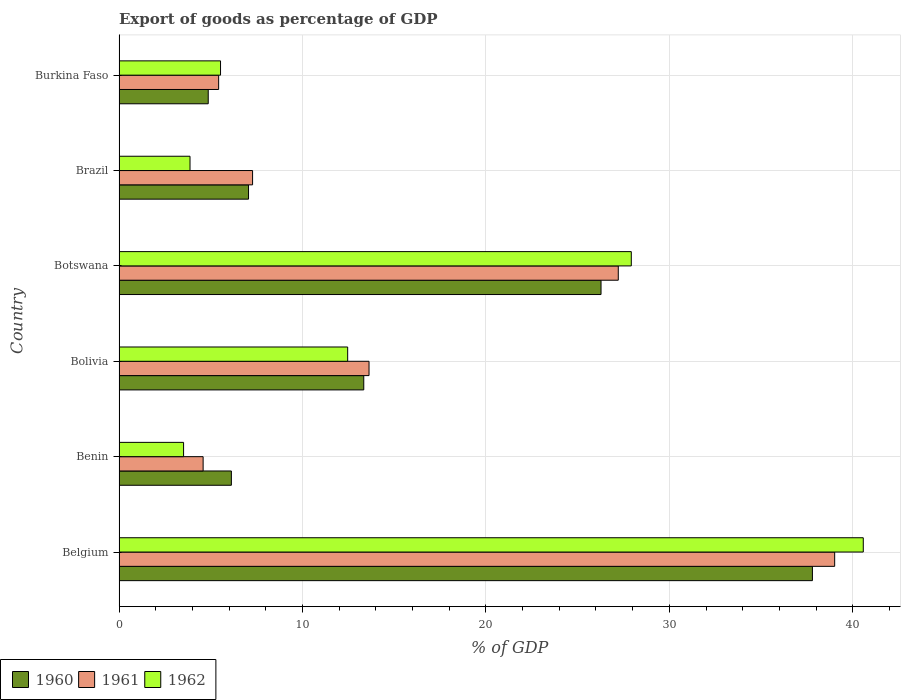How many different coloured bars are there?
Offer a terse response. 3. How many groups of bars are there?
Make the answer very short. 6. Are the number of bars on each tick of the Y-axis equal?
Provide a short and direct response. Yes. What is the label of the 2nd group of bars from the top?
Provide a short and direct response. Brazil. What is the export of goods as percentage of GDP in 1960 in Brazil?
Keep it short and to the point. 7.06. Across all countries, what is the maximum export of goods as percentage of GDP in 1960?
Provide a succinct answer. 37.8. Across all countries, what is the minimum export of goods as percentage of GDP in 1960?
Give a very brief answer. 4.86. In which country was the export of goods as percentage of GDP in 1961 maximum?
Give a very brief answer. Belgium. In which country was the export of goods as percentage of GDP in 1960 minimum?
Make the answer very short. Burkina Faso. What is the total export of goods as percentage of GDP in 1960 in the graph?
Your answer should be compact. 95.46. What is the difference between the export of goods as percentage of GDP in 1960 in Bolivia and that in Burkina Faso?
Your answer should be compact. 8.48. What is the difference between the export of goods as percentage of GDP in 1961 in Brazil and the export of goods as percentage of GDP in 1962 in Botswana?
Give a very brief answer. -20.65. What is the average export of goods as percentage of GDP in 1962 per country?
Your answer should be very brief. 15.65. What is the difference between the export of goods as percentage of GDP in 1962 and export of goods as percentage of GDP in 1961 in Bolivia?
Provide a succinct answer. -1.16. What is the ratio of the export of goods as percentage of GDP in 1961 in Bolivia to that in Brazil?
Offer a terse response. 1.87. Is the export of goods as percentage of GDP in 1961 in Brazil less than that in Burkina Faso?
Keep it short and to the point. No. Is the difference between the export of goods as percentage of GDP in 1962 in Botswana and Brazil greater than the difference between the export of goods as percentage of GDP in 1961 in Botswana and Brazil?
Provide a succinct answer. Yes. What is the difference between the highest and the second highest export of goods as percentage of GDP in 1960?
Offer a very short reply. 11.53. What is the difference between the highest and the lowest export of goods as percentage of GDP in 1962?
Keep it short and to the point. 37.06. What does the 3rd bar from the top in Bolivia represents?
Your answer should be compact. 1960. Is it the case that in every country, the sum of the export of goods as percentage of GDP in 1960 and export of goods as percentage of GDP in 1962 is greater than the export of goods as percentage of GDP in 1961?
Ensure brevity in your answer.  Yes. Where does the legend appear in the graph?
Provide a short and direct response. Bottom left. How are the legend labels stacked?
Your response must be concise. Horizontal. What is the title of the graph?
Keep it short and to the point. Export of goods as percentage of GDP. What is the label or title of the X-axis?
Give a very brief answer. % of GDP. What is the label or title of the Y-axis?
Make the answer very short. Country. What is the % of GDP in 1960 in Belgium?
Offer a very short reply. 37.8. What is the % of GDP in 1961 in Belgium?
Your answer should be very brief. 39.01. What is the % of GDP of 1962 in Belgium?
Your answer should be very brief. 40.57. What is the % of GDP in 1960 in Benin?
Offer a very short reply. 6.12. What is the % of GDP of 1961 in Benin?
Give a very brief answer. 4.58. What is the % of GDP of 1962 in Benin?
Keep it short and to the point. 3.52. What is the % of GDP in 1960 in Bolivia?
Ensure brevity in your answer.  13.34. What is the % of GDP of 1961 in Bolivia?
Ensure brevity in your answer.  13.63. What is the % of GDP of 1962 in Bolivia?
Your response must be concise. 12.46. What is the % of GDP in 1960 in Botswana?
Your answer should be compact. 26.28. What is the % of GDP in 1961 in Botswana?
Your response must be concise. 27.22. What is the % of GDP of 1962 in Botswana?
Your answer should be compact. 27.93. What is the % of GDP in 1960 in Brazil?
Provide a succinct answer. 7.06. What is the % of GDP of 1961 in Brazil?
Offer a very short reply. 7.28. What is the % of GDP in 1962 in Brazil?
Your answer should be very brief. 3.87. What is the % of GDP in 1960 in Burkina Faso?
Your response must be concise. 4.86. What is the % of GDP of 1961 in Burkina Faso?
Give a very brief answer. 5.43. What is the % of GDP of 1962 in Burkina Faso?
Offer a very short reply. 5.53. Across all countries, what is the maximum % of GDP in 1960?
Ensure brevity in your answer.  37.8. Across all countries, what is the maximum % of GDP of 1961?
Ensure brevity in your answer.  39.01. Across all countries, what is the maximum % of GDP of 1962?
Provide a short and direct response. 40.57. Across all countries, what is the minimum % of GDP in 1960?
Keep it short and to the point. 4.86. Across all countries, what is the minimum % of GDP in 1961?
Ensure brevity in your answer.  4.58. Across all countries, what is the minimum % of GDP in 1962?
Your answer should be very brief. 3.52. What is the total % of GDP in 1960 in the graph?
Offer a terse response. 95.46. What is the total % of GDP in 1961 in the graph?
Your answer should be very brief. 97.15. What is the total % of GDP in 1962 in the graph?
Your response must be concise. 93.88. What is the difference between the % of GDP in 1960 in Belgium and that in Benin?
Provide a succinct answer. 31.68. What is the difference between the % of GDP in 1961 in Belgium and that in Benin?
Give a very brief answer. 34.43. What is the difference between the % of GDP in 1962 in Belgium and that in Benin?
Offer a terse response. 37.06. What is the difference between the % of GDP of 1960 in Belgium and that in Bolivia?
Your answer should be very brief. 24.46. What is the difference between the % of GDP in 1961 in Belgium and that in Bolivia?
Give a very brief answer. 25.39. What is the difference between the % of GDP of 1962 in Belgium and that in Bolivia?
Provide a short and direct response. 28.11. What is the difference between the % of GDP in 1960 in Belgium and that in Botswana?
Your answer should be compact. 11.53. What is the difference between the % of GDP of 1961 in Belgium and that in Botswana?
Offer a very short reply. 11.8. What is the difference between the % of GDP in 1962 in Belgium and that in Botswana?
Your answer should be very brief. 12.65. What is the difference between the % of GDP in 1960 in Belgium and that in Brazil?
Make the answer very short. 30.74. What is the difference between the % of GDP of 1961 in Belgium and that in Brazil?
Provide a succinct answer. 31.73. What is the difference between the % of GDP of 1962 in Belgium and that in Brazil?
Provide a succinct answer. 36.7. What is the difference between the % of GDP of 1960 in Belgium and that in Burkina Faso?
Your response must be concise. 32.94. What is the difference between the % of GDP in 1961 in Belgium and that in Burkina Faso?
Your answer should be compact. 33.58. What is the difference between the % of GDP of 1962 in Belgium and that in Burkina Faso?
Offer a very short reply. 35.04. What is the difference between the % of GDP of 1960 in Benin and that in Bolivia?
Give a very brief answer. -7.22. What is the difference between the % of GDP in 1961 in Benin and that in Bolivia?
Provide a succinct answer. -9.04. What is the difference between the % of GDP of 1962 in Benin and that in Bolivia?
Your answer should be very brief. -8.95. What is the difference between the % of GDP in 1960 in Benin and that in Botswana?
Give a very brief answer. -20.15. What is the difference between the % of GDP in 1961 in Benin and that in Botswana?
Your answer should be very brief. -22.63. What is the difference between the % of GDP of 1962 in Benin and that in Botswana?
Give a very brief answer. -24.41. What is the difference between the % of GDP of 1960 in Benin and that in Brazil?
Your response must be concise. -0.94. What is the difference between the % of GDP in 1961 in Benin and that in Brazil?
Provide a short and direct response. -2.7. What is the difference between the % of GDP of 1962 in Benin and that in Brazil?
Keep it short and to the point. -0.35. What is the difference between the % of GDP of 1960 in Benin and that in Burkina Faso?
Provide a short and direct response. 1.26. What is the difference between the % of GDP in 1961 in Benin and that in Burkina Faso?
Make the answer very short. -0.85. What is the difference between the % of GDP in 1962 in Benin and that in Burkina Faso?
Your answer should be very brief. -2.01. What is the difference between the % of GDP of 1960 in Bolivia and that in Botswana?
Provide a short and direct response. -12.93. What is the difference between the % of GDP of 1961 in Bolivia and that in Botswana?
Your response must be concise. -13.59. What is the difference between the % of GDP in 1962 in Bolivia and that in Botswana?
Provide a succinct answer. -15.46. What is the difference between the % of GDP in 1960 in Bolivia and that in Brazil?
Your response must be concise. 6.28. What is the difference between the % of GDP of 1961 in Bolivia and that in Brazil?
Ensure brevity in your answer.  6.35. What is the difference between the % of GDP of 1962 in Bolivia and that in Brazil?
Your response must be concise. 8.6. What is the difference between the % of GDP in 1960 in Bolivia and that in Burkina Faso?
Make the answer very short. 8.48. What is the difference between the % of GDP of 1961 in Bolivia and that in Burkina Faso?
Offer a very short reply. 8.2. What is the difference between the % of GDP in 1962 in Bolivia and that in Burkina Faso?
Provide a short and direct response. 6.93. What is the difference between the % of GDP of 1960 in Botswana and that in Brazil?
Offer a terse response. 19.22. What is the difference between the % of GDP of 1961 in Botswana and that in Brazil?
Your answer should be very brief. 19.94. What is the difference between the % of GDP in 1962 in Botswana and that in Brazil?
Offer a terse response. 24.06. What is the difference between the % of GDP of 1960 in Botswana and that in Burkina Faso?
Your response must be concise. 21.41. What is the difference between the % of GDP of 1961 in Botswana and that in Burkina Faso?
Keep it short and to the point. 21.79. What is the difference between the % of GDP of 1962 in Botswana and that in Burkina Faso?
Give a very brief answer. 22.39. What is the difference between the % of GDP of 1960 in Brazil and that in Burkina Faso?
Provide a short and direct response. 2.2. What is the difference between the % of GDP in 1961 in Brazil and that in Burkina Faso?
Your answer should be compact. 1.85. What is the difference between the % of GDP in 1962 in Brazil and that in Burkina Faso?
Make the answer very short. -1.66. What is the difference between the % of GDP of 1960 in Belgium and the % of GDP of 1961 in Benin?
Your response must be concise. 33.22. What is the difference between the % of GDP of 1960 in Belgium and the % of GDP of 1962 in Benin?
Your answer should be very brief. 34.28. What is the difference between the % of GDP in 1961 in Belgium and the % of GDP in 1962 in Benin?
Make the answer very short. 35.5. What is the difference between the % of GDP of 1960 in Belgium and the % of GDP of 1961 in Bolivia?
Keep it short and to the point. 24.17. What is the difference between the % of GDP of 1960 in Belgium and the % of GDP of 1962 in Bolivia?
Offer a very short reply. 25.34. What is the difference between the % of GDP in 1961 in Belgium and the % of GDP in 1962 in Bolivia?
Make the answer very short. 26.55. What is the difference between the % of GDP in 1960 in Belgium and the % of GDP in 1961 in Botswana?
Provide a short and direct response. 10.58. What is the difference between the % of GDP of 1960 in Belgium and the % of GDP of 1962 in Botswana?
Your answer should be very brief. 9.87. What is the difference between the % of GDP of 1961 in Belgium and the % of GDP of 1962 in Botswana?
Offer a terse response. 11.09. What is the difference between the % of GDP in 1960 in Belgium and the % of GDP in 1961 in Brazil?
Make the answer very short. 30.52. What is the difference between the % of GDP in 1960 in Belgium and the % of GDP in 1962 in Brazil?
Offer a very short reply. 33.93. What is the difference between the % of GDP in 1961 in Belgium and the % of GDP in 1962 in Brazil?
Keep it short and to the point. 35.14. What is the difference between the % of GDP of 1960 in Belgium and the % of GDP of 1961 in Burkina Faso?
Ensure brevity in your answer.  32.37. What is the difference between the % of GDP in 1960 in Belgium and the % of GDP in 1962 in Burkina Faso?
Offer a very short reply. 32.27. What is the difference between the % of GDP of 1961 in Belgium and the % of GDP of 1962 in Burkina Faso?
Give a very brief answer. 33.48. What is the difference between the % of GDP of 1960 in Benin and the % of GDP of 1961 in Bolivia?
Keep it short and to the point. -7.5. What is the difference between the % of GDP in 1960 in Benin and the % of GDP in 1962 in Bolivia?
Keep it short and to the point. -6.34. What is the difference between the % of GDP in 1961 in Benin and the % of GDP in 1962 in Bolivia?
Ensure brevity in your answer.  -7.88. What is the difference between the % of GDP of 1960 in Benin and the % of GDP of 1961 in Botswana?
Your answer should be very brief. -21.09. What is the difference between the % of GDP of 1960 in Benin and the % of GDP of 1962 in Botswana?
Your response must be concise. -21.8. What is the difference between the % of GDP in 1961 in Benin and the % of GDP in 1962 in Botswana?
Ensure brevity in your answer.  -23.34. What is the difference between the % of GDP in 1960 in Benin and the % of GDP in 1961 in Brazil?
Ensure brevity in your answer.  -1.16. What is the difference between the % of GDP in 1960 in Benin and the % of GDP in 1962 in Brazil?
Give a very brief answer. 2.26. What is the difference between the % of GDP in 1961 in Benin and the % of GDP in 1962 in Brazil?
Ensure brevity in your answer.  0.71. What is the difference between the % of GDP in 1960 in Benin and the % of GDP in 1961 in Burkina Faso?
Provide a succinct answer. 0.69. What is the difference between the % of GDP in 1960 in Benin and the % of GDP in 1962 in Burkina Faso?
Your response must be concise. 0.59. What is the difference between the % of GDP in 1961 in Benin and the % of GDP in 1962 in Burkina Faso?
Give a very brief answer. -0.95. What is the difference between the % of GDP in 1960 in Bolivia and the % of GDP in 1961 in Botswana?
Provide a succinct answer. -13.88. What is the difference between the % of GDP of 1960 in Bolivia and the % of GDP of 1962 in Botswana?
Your answer should be compact. -14.58. What is the difference between the % of GDP in 1961 in Bolivia and the % of GDP in 1962 in Botswana?
Your response must be concise. -14.3. What is the difference between the % of GDP in 1960 in Bolivia and the % of GDP in 1961 in Brazil?
Ensure brevity in your answer.  6.06. What is the difference between the % of GDP of 1960 in Bolivia and the % of GDP of 1962 in Brazil?
Offer a very short reply. 9.47. What is the difference between the % of GDP in 1961 in Bolivia and the % of GDP in 1962 in Brazil?
Give a very brief answer. 9.76. What is the difference between the % of GDP in 1960 in Bolivia and the % of GDP in 1961 in Burkina Faso?
Your answer should be compact. 7.91. What is the difference between the % of GDP of 1960 in Bolivia and the % of GDP of 1962 in Burkina Faso?
Offer a terse response. 7.81. What is the difference between the % of GDP of 1961 in Bolivia and the % of GDP of 1962 in Burkina Faso?
Your answer should be very brief. 8.1. What is the difference between the % of GDP in 1960 in Botswana and the % of GDP in 1961 in Brazil?
Ensure brevity in your answer.  19. What is the difference between the % of GDP in 1960 in Botswana and the % of GDP in 1962 in Brazil?
Ensure brevity in your answer.  22.41. What is the difference between the % of GDP of 1961 in Botswana and the % of GDP of 1962 in Brazil?
Give a very brief answer. 23.35. What is the difference between the % of GDP in 1960 in Botswana and the % of GDP in 1961 in Burkina Faso?
Offer a very short reply. 20.85. What is the difference between the % of GDP in 1960 in Botswana and the % of GDP in 1962 in Burkina Faso?
Make the answer very short. 20.74. What is the difference between the % of GDP in 1961 in Botswana and the % of GDP in 1962 in Burkina Faso?
Offer a very short reply. 21.68. What is the difference between the % of GDP of 1960 in Brazil and the % of GDP of 1961 in Burkina Faso?
Provide a succinct answer. 1.63. What is the difference between the % of GDP in 1960 in Brazil and the % of GDP in 1962 in Burkina Faso?
Keep it short and to the point. 1.53. What is the difference between the % of GDP of 1961 in Brazil and the % of GDP of 1962 in Burkina Faso?
Provide a succinct answer. 1.75. What is the average % of GDP in 1960 per country?
Make the answer very short. 15.91. What is the average % of GDP in 1961 per country?
Your answer should be compact. 16.19. What is the average % of GDP in 1962 per country?
Ensure brevity in your answer.  15.65. What is the difference between the % of GDP in 1960 and % of GDP in 1961 in Belgium?
Ensure brevity in your answer.  -1.21. What is the difference between the % of GDP of 1960 and % of GDP of 1962 in Belgium?
Give a very brief answer. -2.77. What is the difference between the % of GDP of 1961 and % of GDP of 1962 in Belgium?
Ensure brevity in your answer.  -1.56. What is the difference between the % of GDP of 1960 and % of GDP of 1961 in Benin?
Offer a terse response. 1.54. What is the difference between the % of GDP of 1960 and % of GDP of 1962 in Benin?
Ensure brevity in your answer.  2.61. What is the difference between the % of GDP in 1961 and % of GDP in 1962 in Benin?
Provide a succinct answer. 1.07. What is the difference between the % of GDP in 1960 and % of GDP in 1961 in Bolivia?
Your response must be concise. -0.29. What is the difference between the % of GDP in 1960 and % of GDP in 1962 in Bolivia?
Make the answer very short. 0.88. What is the difference between the % of GDP of 1961 and % of GDP of 1962 in Bolivia?
Your response must be concise. 1.16. What is the difference between the % of GDP of 1960 and % of GDP of 1961 in Botswana?
Your answer should be compact. -0.94. What is the difference between the % of GDP of 1960 and % of GDP of 1962 in Botswana?
Give a very brief answer. -1.65. What is the difference between the % of GDP in 1961 and % of GDP in 1962 in Botswana?
Your answer should be very brief. -0.71. What is the difference between the % of GDP of 1960 and % of GDP of 1961 in Brazil?
Your response must be concise. -0.22. What is the difference between the % of GDP of 1960 and % of GDP of 1962 in Brazil?
Keep it short and to the point. 3.19. What is the difference between the % of GDP of 1961 and % of GDP of 1962 in Brazil?
Provide a short and direct response. 3.41. What is the difference between the % of GDP of 1960 and % of GDP of 1961 in Burkina Faso?
Provide a short and direct response. -0.57. What is the difference between the % of GDP in 1960 and % of GDP in 1962 in Burkina Faso?
Make the answer very short. -0.67. What is the difference between the % of GDP in 1961 and % of GDP in 1962 in Burkina Faso?
Offer a very short reply. -0.1. What is the ratio of the % of GDP of 1960 in Belgium to that in Benin?
Provide a succinct answer. 6.17. What is the ratio of the % of GDP in 1961 in Belgium to that in Benin?
Your answer should be compact. 8.51. What is the ratio of the % of GDP of 1962 in Belgium to that in Benin?
Give a very brief answer. 11.53. What is the ratio of the % of GDP of 1960 in Belgium to that in Bolivia?
Make the answer very short. 2.83. What is the ratio of the % of GDP in 1961 in Belgium to that in Bolivia?
Your response must be concise. 2.86. What is the ratio of the % of GDP in 1962 in Belgium to that in Bolivia?
Your answer should be compact. 3.26. What is the ratio of the % of GDP of 1960 in Belgium to that in Botswana?
Provide a succinct answer. 1.44. What is the ratio of the % of GDP in 1961 in Belgium to that in Botswana?
Keep it short and to the point. 1.43. What is the ratio of the % of GDP of 1962 in Belgium to that in Botswana?
Your answer should be very brief. 1.45. What is the ratio of the % of GDP of 1960 in Belgium to that in Brazil?
Keep it short and to the point. 5.35. What is the ratio of the % of GDP of 1961 in Belgium to that in Brazil?
Provide a short and direct response. 5.36. What is the ratio of the % of GDP of 1962 in Belgium to that in Brazil?
Provide a short and direct response. 10.49. What is the ratio of the % of GDP in 1960 in Belgium to that in Burkina Faso?
Your answer should be compact. 7.77. What is the ratio of the % of GDP in 1961 in Belgium to that in Burkina Faso?
Provide a succinct answer. 7.19. What is the ratio of the % of GDP in 1962 in Belgium to that in Burkina Faso?
Offer a very short reply. 7.33. What is the ratio of the % of GDP in 1960 in Benin to that in Bolivia?
Ensure brevity in your answer.  0.46. What is the ratio of the % of GDP in 1961 in Benin to that in Bolivia?
Provide a succinct answer. 0.34. What is the ratio of the % of GDP of 1962 in Benin to that in Bolivia?
Ensure brevity in your answer.  0.28. What is the ratio of the % of GDP of 1960 in Benin to that in Botswana?
Your response must be concise. 0.23. What is the ratio of the % of GDP of 1961 in Benin to that in Botswana?
Your answer should be compact. 0.17. What is the ratio of the % of GDP of 1962 in Benin to that in Botswana?
Offer a very short reply. 0.13. What is the ratio of the % of GDP in 1960 in Benin to that in Brazil?
Ensure brevity in your answer.  0.87. What is the ratio of the % of GDP in 1961 in Benin to that in Brazil?
Make the answer very short. 0.63. What is the ratio of the % of GDP of 1962 in Benin to that in Brazil?
Your response must be concise. 0.91. What is the ratio of the % of GDP in 1960 in Benin to that in Burkina Faso?
Offer a very short reply. 1.26. What is the ratio of the % of GDP of 1961 in Benin to that in Burkina Faso?
Make the answer very short. 0.84. What is the ratio of the % of GDP in 1962 in Benin to that in Burkina Faso?
Make the answer very short. 0.64. What is the ratio of the % of GDP of 1960 in Bolivia to that in Botswana?
Ensure brevity in your answer.  0.51. What is the ratio of the % of GDP of 1961 in Bolivia to that in Botswana?
Provide a short and direct response. 0.5. What is the ratio of the % of GDP of 1962 in Bolivia to that in Botswana?
Offer a terse response. 0.45. What is the ratio of the % of GDP of 1960 in Bolivia to that in Brazil?
Provide a short and direct response. 1.89. What is the ratio of the % of GDP of 1961 in Bolivia to that in Brazil?
Provide a short and direct response. 1.87. What is the ratio of the % of GDP in 1962 in Bolivia to that in Brazil?
Your answer should be compact. 3.22. What is the ratio of the % of GDP in 1960 in Bolivia to that in Burkina Faso?
Keep it short and to the point. 2.74. What is the ratio of the % of GDP of 1961 in Bolivia to that in Burkina Faso?
Ensure brevity in your answer.  2.51. What is the ratio of the % of GDP of 1962 in Bolivia to that in Burkina Faso?
Give a very brief answer. 2.25. What is the ratio of the % of GDP in 1960 in Botswana to that in Brazil?
Your answer should be very brief. 3.72. What is the ratio of the % of GDP in 1961 in Botswana to that in Brazil?
Provide a short and direct response. 3.74. What is the ratio of the % of GDP in 1962 in Botswana to that in Brazil?
Your answer should be compact. 7.22. What is the ratio of the % of GDP in 1960 in Botswana to that in Burkina Faso?
Ensure brevity in your answer.  5.4. What is the ratio of the % of GDP in 1961 in Botswana to that in Burkina Faso?
Your answer should be very brief. 5.01. What is the ratio of the % of GDP in 1962 in Botswana to that in Burkina Faso?
Your response must be concise. 5.05. What is the ratio of the % of GDP in 1960 in Brazil to that in Burkina Faso?
Offer a very short reply. 1.45. What is the ratio of the % of GDP in 1961 in Brazil to that in Burkina Faso?
Offer a terse response. 1.34. What is the ratio of the % of GDP of 1962 in Brazil to that in Burkina Faso?
Offer a terse response. 0.7. What is the difference between the highest and the second highest % of GDP of 1960?
Give a very brief answer. 11.53. What is the difference between the highest and the second highest % of GDP of 1961?
Your answer should be very brief. 11.8. What is the difference between the highest and the second highest % of GDP of 1962?
Offer a terse response. 12.65. What is the difference between the highest and the lowest % of GDP in 1960?
Make the answer very short. 32.94. What is the difference between the highest and the lowest % of GDP in 1961?
Provide a succinct answer. 34.43. What is the difference between the highest and the lowest % of GDP in 1962?
Offer a very short reply. 37.06. 